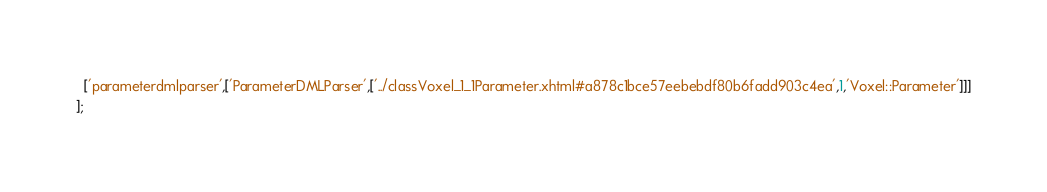Convert code to text. <code><loc_0><loc_0><loc_500><loc_500><_JavaScript_>  ['parameterdmlparser',['ParameterDMLParser',['../classVoxel_1_1Parameter.xhtml#a878c1bce57eebebdf80b6fadd903c4ea',1,'Voxel::Parameter']]]
];
</code> 